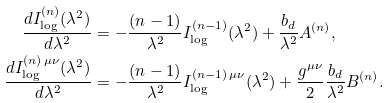<formula> <loc_0><loc_0><loc_500><loc_500>\frac { d I _ { \log } ^ { ( n ) } ( \lambda ^ { 2 } ) } { d \lambda ^ { 2 } } & = - \frac { ( n - 1 ) } { \lambda ^ { 2 } } I _ { \log } ^ { ( n - 1 ) } ( \lambda ^ { 2 } ) + \frac { b _ { d } } { \lambda ^ { 2 } } A ^ { ( n ) } , \\ \frac { d I _ { \log } ^ { ( n ) \, \mu \nu } ( \lambda ^ { 2 } ) } { d \lambda ^ { 2 } } & = - \frac { ( n - 1 ) } { \lambda ^ { 2 } } I _ { \log } ^ { ( n - 1 ) \, \mu \nu } ( \lambda ^ { 2 } ) + \frac { g ^ { \mu \nu } } { 2 } \frac { b _ { d } } { \lambda ^ { 2 } } B ^ { ( n ) } .</formula> 